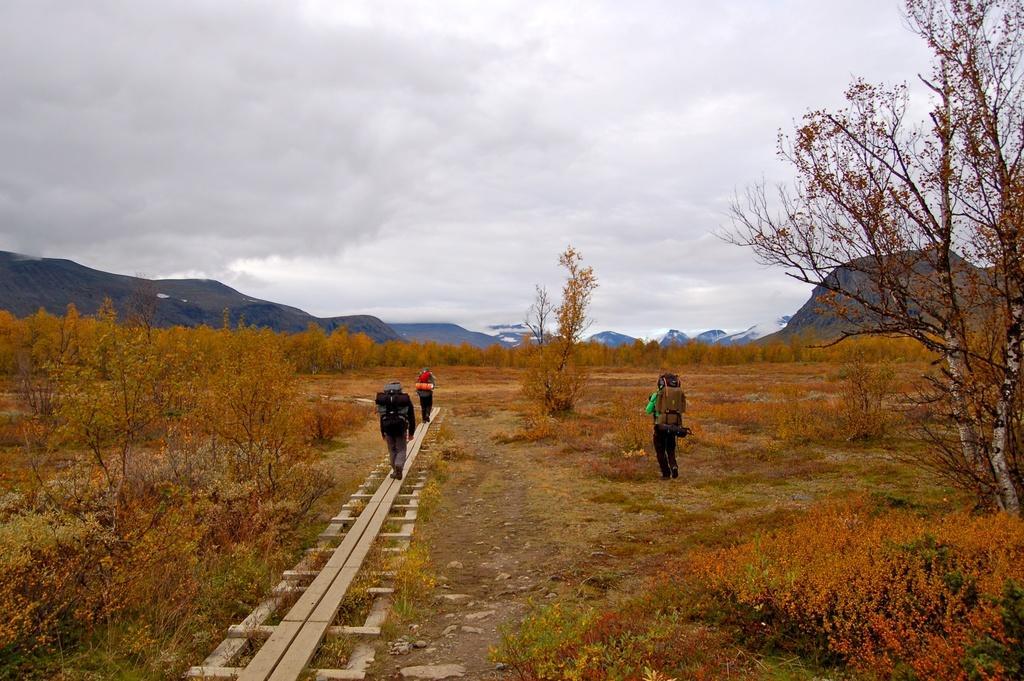Describe this image in one or two sentences. In this image I can see in the middle two persons are walking on the wooden things. They wore bags, on the right side there is another person, there are trees, at the back side there are hills, at the top it is the cloudy sky. 